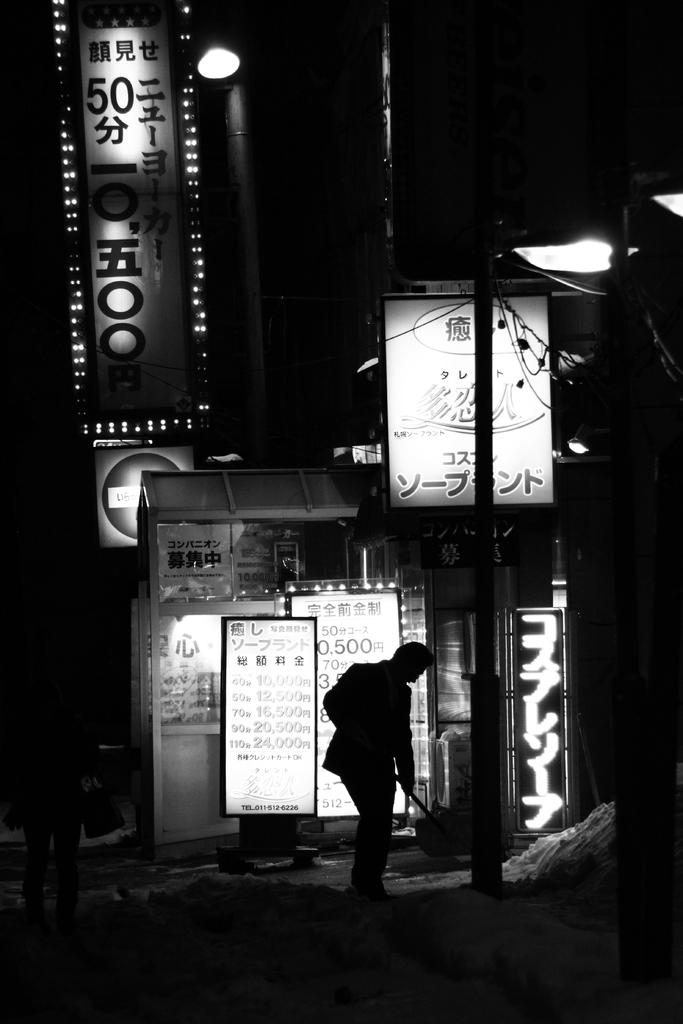Who or what is present in the image? There is a person in the image. What else can be seen in the image besides the person? There are banners and lights in the image. Can you describe the overall appearance of the image? The image appears to be dark. Is there a store nearby where the person can use their credit card? There is no information about a store or credit card usage in the image. 